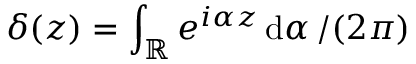Convert formula to latex. <formula><loc_0><loc_0><loc_500><loc_500>\delta ( z ) = \int _ { \mathbb { R } } e ^ { i \alpha z } \, { d \alpha } \, / ( 2 \pi )</formula> 